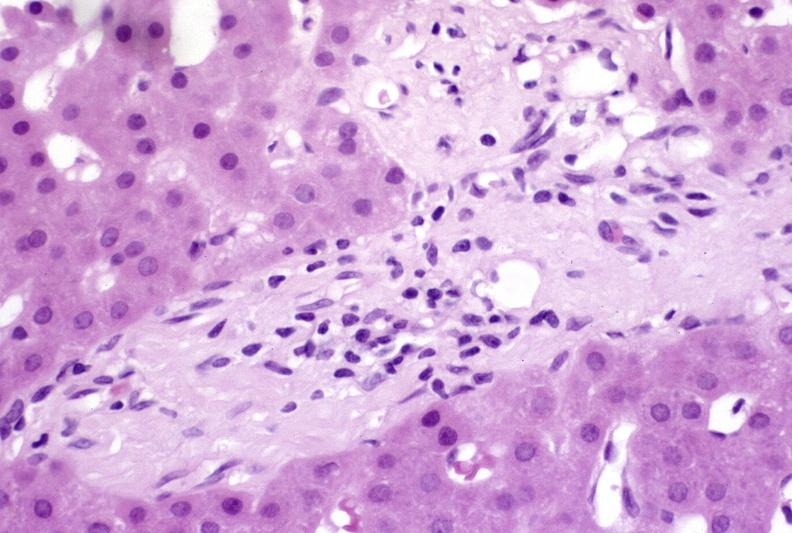s liver present?
Answer the question using a single word or phrase. Yes 